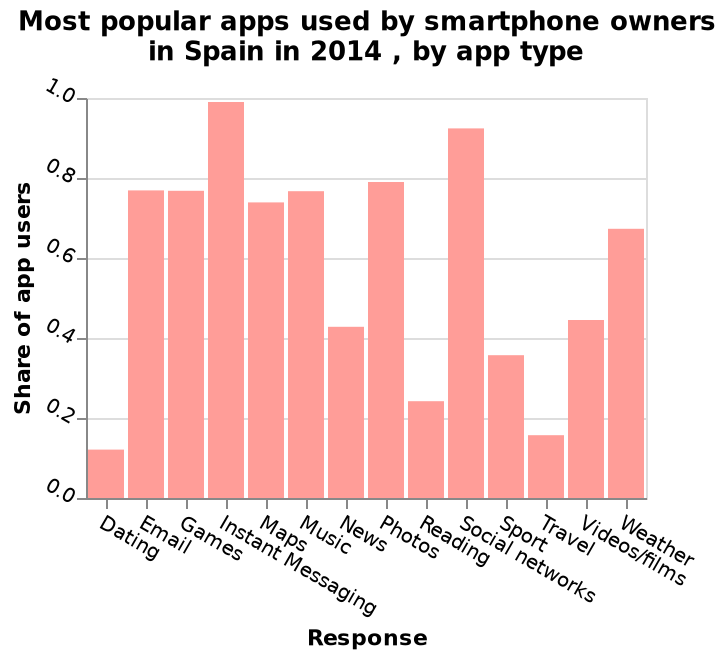<image>
Offer a thorough analysis of the image. Dating has the least share of app users at just over 0.1 and Instant messaging the most at almost 1.0. Social networks are the next closely ranking in popularity share. Email, games, maps and music are all very close in terms of share of app users at just under 0.8. Travel is also rather unpopular alongside dating with only. What does the bar height in the diagram represent? The bar height represents the share or percentage of app users for each app type. Describe the following image in detail Here a is a bar diagram called Most popular apps used by smartphone owners in Spain in 2014 , by app type. The x-axis shows Response while the y-axis shows Share of app users. What app category followed instant messaging in popularity among smartphone owners in Spain in 2014? Social networks. 